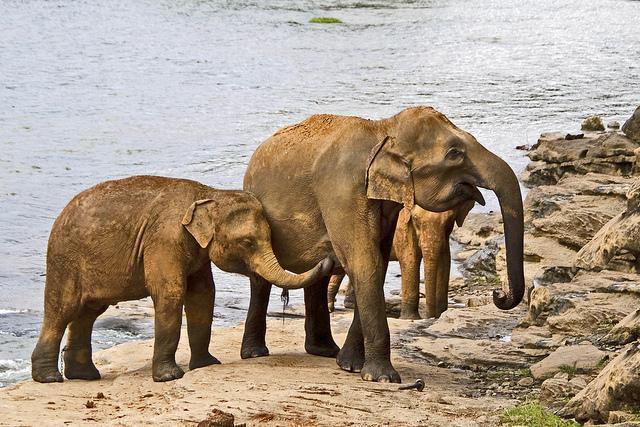How many elephants are there?
Give a very brief answer. 3. How many elephants are in the picture?
Give a very brief answer. 3. 